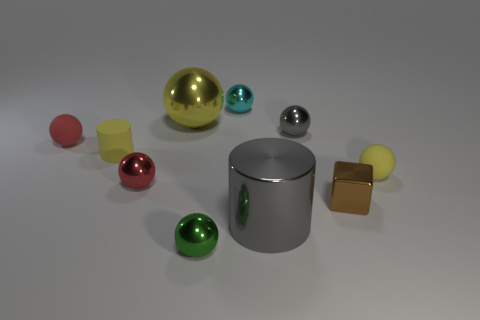There is a cylinder that is behind the small yellow matte sphere; does it have the same color as the big metal sphere?
Ensure brevity in your answer.  Yes. What number of red spheres have the same size as the metal block?
Ensure brevity in your answer.  2. What is the shape of the yellow thing that is the same material as the small gray ball?
Offer a very short reply. Sphere. Is there a sphere that has the same color as the matte cylinder?
Keep it short and to the point. Yes. What is the material of the tiny yellow sphere?
Keep it short and to the point. Rubber. What number of objects are either gray rubber cylinders or tiny metal objects?
Offer a terse response. 5. What is the size of the red sphere that is on the left side of the tiny yellow cylinder?
Provide a short and direct response. Small. How many other objects are the same material as the yellow cylinder?
Make the answer very short. 2. Are there any shiny blocks that are in front of the small yellow rubber thing right of the small brown object?
Provide a succinct answer. Yes. Is there anything else that is the same shape as the brown shiny thing?
Provide a succinct answer. No. 